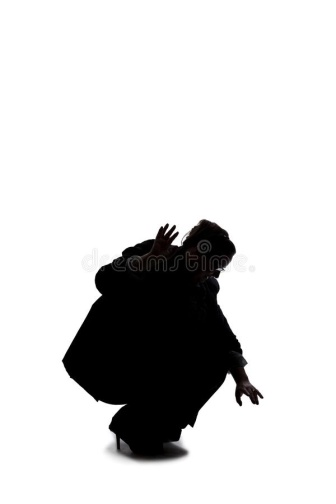Imagine there is music playing in the background of this scene. What type of music would it be and why? The music playing in the background of this evocative scene would likely be an eerie, ambient soundtrack filled with a slow, creeping melody. Sharp, staccato notes on a violin would cut through an undercurrent of deep, resonant drones, creating a sense of suspense and foreboding. Occasional soft, rhythmic beats might echo the tense movements of the figure, emphasizing their poised readiness. This type of music would enhance the dramatic tension and add a layer of emotional depth to the visual narrative, making the viewer feel the anticipation and mystery of the moment even more acutely. 